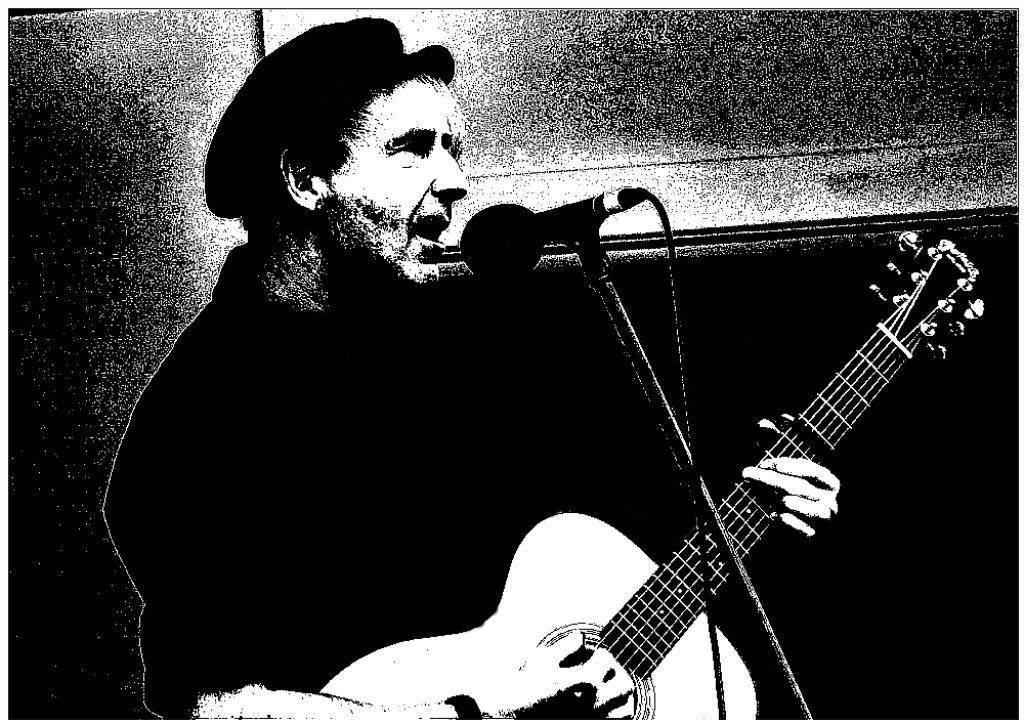What is the main subject of the image? The main subject of the image is a man. What is the man wearing on his head? The man is wearing a cap. What is the man holding in the image? The man is holding a guitar. What is the man doing with the guitar? The man is playing the guitar. What is the man doing while playing the guitar? The man is singing on a microphone. What can be seen in the background of the image? There is a wall in the background of the image. How many jellyfish are swimming in the image? There are no jellyfish present in the image. 